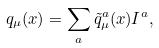Convert formula to latex. <formula><loc_0><loc_0><loc_500><loc_500>q _ { \mu } ( x ) = \sum _ { a } \tilde { q } ^ { a } _ { \mu } ( x ) I ^ { a } ,</formula> 